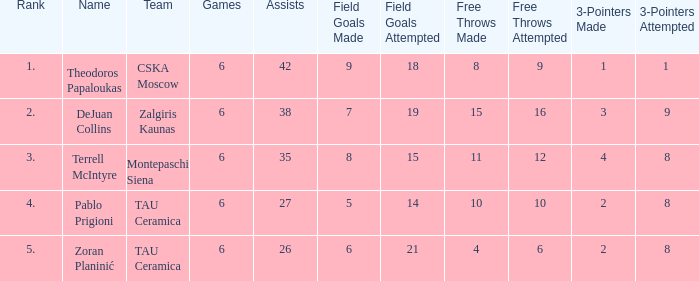What is the least number of assists among players ranked 2? 38.0. 